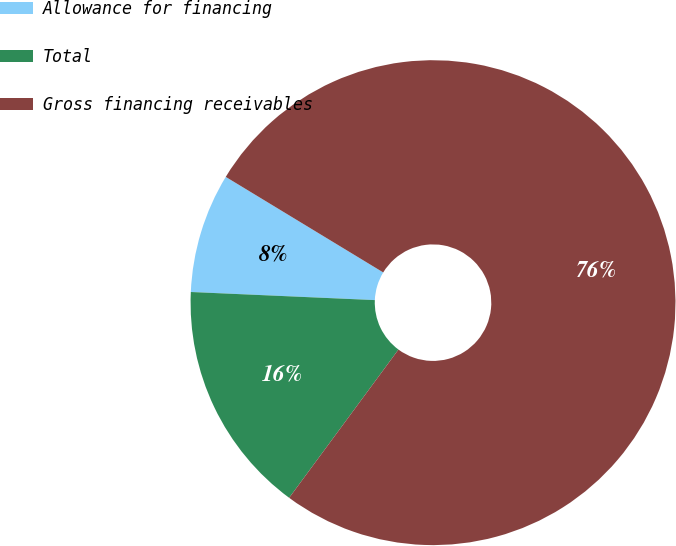Convert chart. <chart><loc_0><loc_0><loc_500><loc_500><pie_chart><fcel>Allowance for financing<fcel>Total<fcel>Gross financing receivables<nl><fcel>7.98%<fcel>15.59%<fcel>76.43%<nl></chart> 